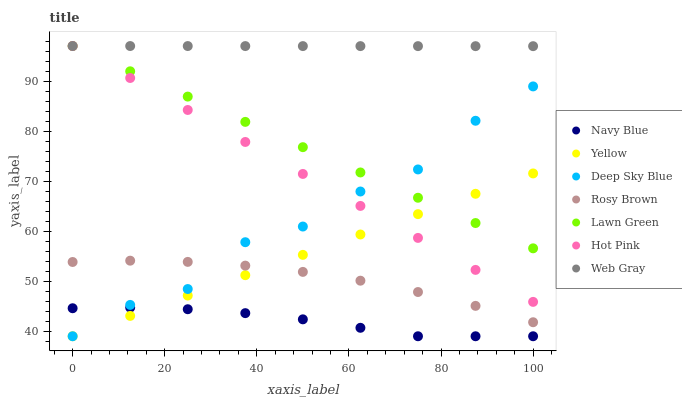Does Navy Blue have the minimum area under the curve?
Answer yes or no. Yes. Does Web Gray have the maximum area under the curve?
Answer yes or no. Yes. Does Rosy Brown have the minimum area under the curve?
Answer yes or no. No. Does Rosy Brown have the maximum area under the curve?
Answer yes or no. No. Is Hot Pink the smoothest?
Answer yes or no. Yes. Is Deep Sky Blue the roughest?
Answer yes or no. Yes. Is Rosy Brown the smoothest?
Answer yes or no. No. Is Rosy Brown the roughest?
Answer yes or no. No. Does Navy Blue have the lowest value?
Answer yes or no. Yes. Does Rosy Brown have the lowest value?
Answer yes or no. No. Does Web Gray have the highest value?
Answer yes or no. Yes. Does Rosy Brown have the highest value?
Answer yes or no. No. Is Rosy Brown less than Web Gray?
Answer yes or no. Yes. Is Web Gray greater than Navy Blue?
Answer yes or no. Yes. Does Lawn Green intersect Hot Pink?
Answer yes or no. Yes. Is Lawn Green less than Hot Pink?
Answer yes or no. No. Is Lawn Green greater than Hot Pink?
Answer yes or no. No. Does Rosy Brown intersect Web Gray?
Answer yes or no. No. 